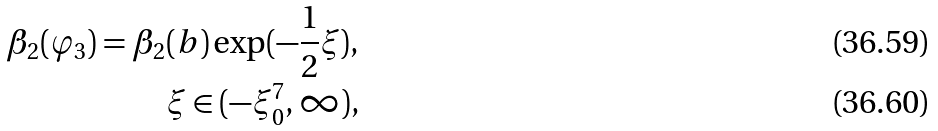Convert formula to latex. <formula><loc_0><loc_0><loc_500><loc_500>\beta _ { 2 } ( \varphi _ { 3 } ) = \beta _ { 2 } ( b ) \exp ( - \frac { 1 } { 2 } \xi ) , \\ \quad \xi \in ( - \xi _ { 0 } ^ { 7 } , \infty ) ,</formula> 